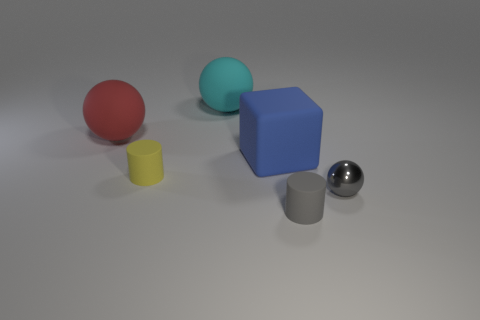Subtract all cylinders. How many objects are left? 4 Subtract all gray cylinders. How many cylinders are left? 1 Add 3 small cyan things. How many objects exist? 9 Subtract all tiny metal balls. How many balls are left? 2 Subtract 1 gray spheres. How many objects are left? 5 Subtract 1 cubes. How many cubes are left? 0 Subtract all cyan blocks. Subtract all gray cylinders. How many blocks are left? 1 Subtract all gray cylinders. How many cyan cubes are left? 0 Subtract all yellow rubber spheres. Subtract all small gray spheres. How many objects are left? 5 Add 5 tiny things. How many tiny things are left? 8 